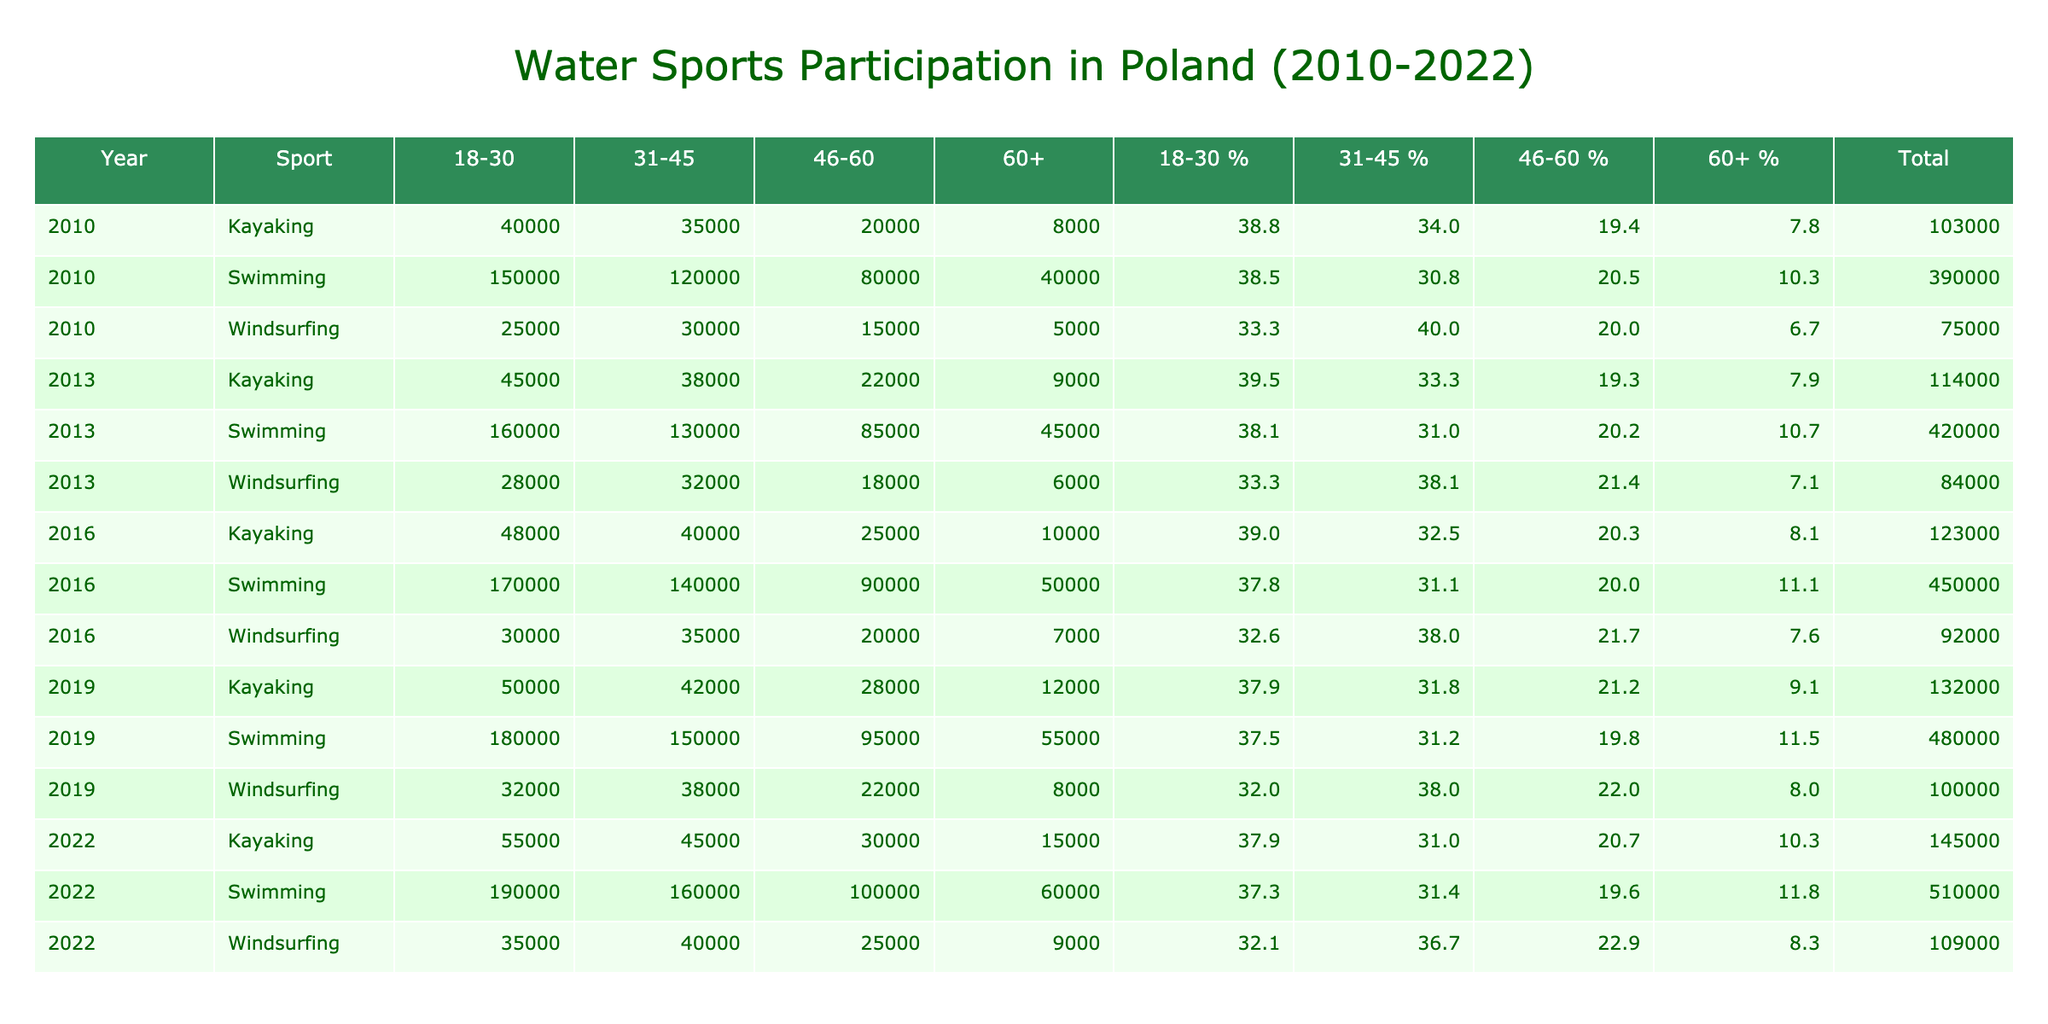What was the total number of participants in Swimming in 2016? By looking at the table, I find the entries for Swimming in 2016 across different age groups: 170000 (18-30), 140000 (31-45), 90000 (46-60), and 50000 (60+). Adding these values together gives: 170000 + 140000 + 90000 + 50000 = 450000.
Answer: 450000 What percentage of participants were aged 31-45 for Kayaking in 2022? In 2022, the total number of Kayaking participants is 55000 (18-30), 45000 (31-45), 30000 (46-60), and 15000 (60+). First, I calculate the total: 55000 + 45000 + 30000 + 15000 = 145000. Next, the number of participants aged 31-45 is 45000. The percentage is calculated as (45000 / 145000) * 100 which equals 31.0%.
Answer: 31.0% Was the number of Windsurfing participants in 2013 higher than in 2019 across all age groups combined? For Windsurfing, the total participants in 2013 are: 28000 (18-30), 32000 (31-45), 18000 (46-60), and 6000 (60+), giving a sum of 28000 + 32000 + 18000 + 6000 = 84000. In 2019, the participants are: 32000 (18-30), 38000 (31-45), 22000 (46-60), and 8000 (60+), summing up to 32000 + 38000 + 22000 + 8000 = 100000. Since 84000 is less than 100000, the answer is no.
Answer: No What is the trend in the participation of Swimming for the 46-60 age group from 2010 to 2022? In 2010, the participants were 80000, in 2013 it was 85000, in 2016 it rose to 90000, in 2019 it slightly increased to 95000, and in 2022 it reached 100000. Observing these numbers, there is a consistent increase of 5000 participants every three years.
Answer: Increasing How many more participants aged 60+ participated in Kayaking in 2016 compared to 2013? In 2016, the number of participants aged 60+ for Kayaking is 10000. In 2013, it was 9000. To find the difference, I subtract the 2013 value from the 2016 value: 10000 - 9000 = 1000.
Answer: 1000 What percentage of total Swimming participants were over 60 years old in 2022? First, I find out the total number of Swimming participants in 2022: 190000 (18-30), 160000 (31-45), 100000 (46-60), and 60000 (60+). The total is 190000 + 160000 + 100000 + 60000 = 510000. The number of participants over 60 is 60000. The percentage is then (60000 / 510000) * 100 which is approximately 11.8%.
Answer: 11.8% What was the difference in the total number of Kayaking participants between 2010 and 2022? In 2010, the total for Kayaking is: 40000 (18-30), 35000 (31-45), 20000 (46-60), and 8000 (60+), summing to 40000 + 35000 + 20000 + 8000 = 113000. In 2022, the totals are: 55000 (18-30), 45000 (31-45), 30000 (46-60), and 15000 (60+), which total to 55000 + 45000 + 30000 + 15000 = 145000. The difference is 145000 - 113000 = 32000.
Answer: 32000 In which year was the participation in Windsurfing the highest for the age group 31-45? Reviewing the table, for 31-45 age group in Windsurfing, the participants are: 30000 in 2010, 32000 in 2013, 35000 in 2016, 38000 in 2019, and 40000 in 2022. The highest number appears in 2022 with 40000 participants.
Answer: 2022 